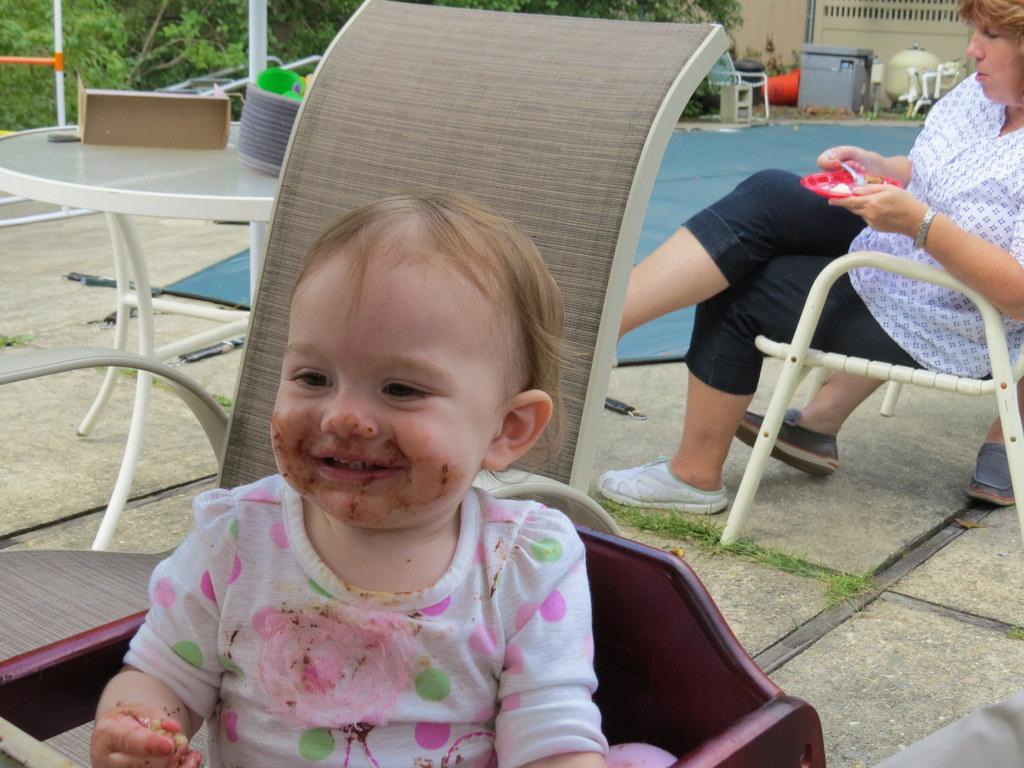In one or two sentences, can you explain what this image depicts? this picture shows a man and a baby seated on the chair and we see woman holding a plate in her hand and taking some food and we see couple of trees 